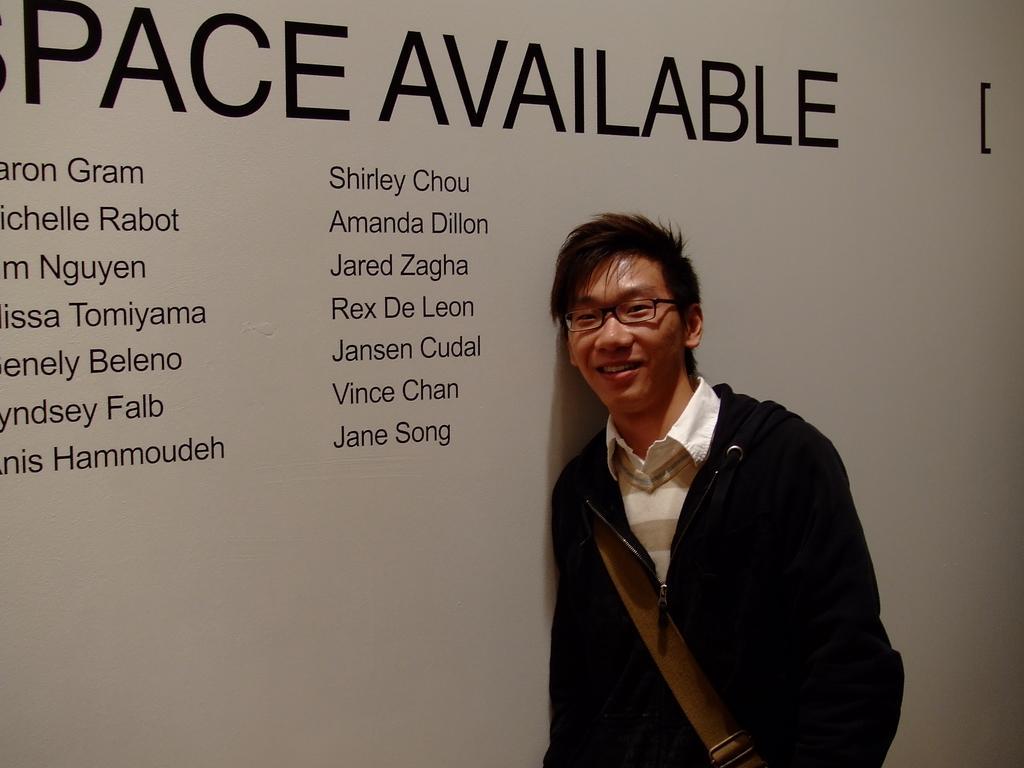Can you describe this image briefly? In this image there is a person wearing a spectacle, his smiling, may be standing in front of the wall, on the wall there is a text. 